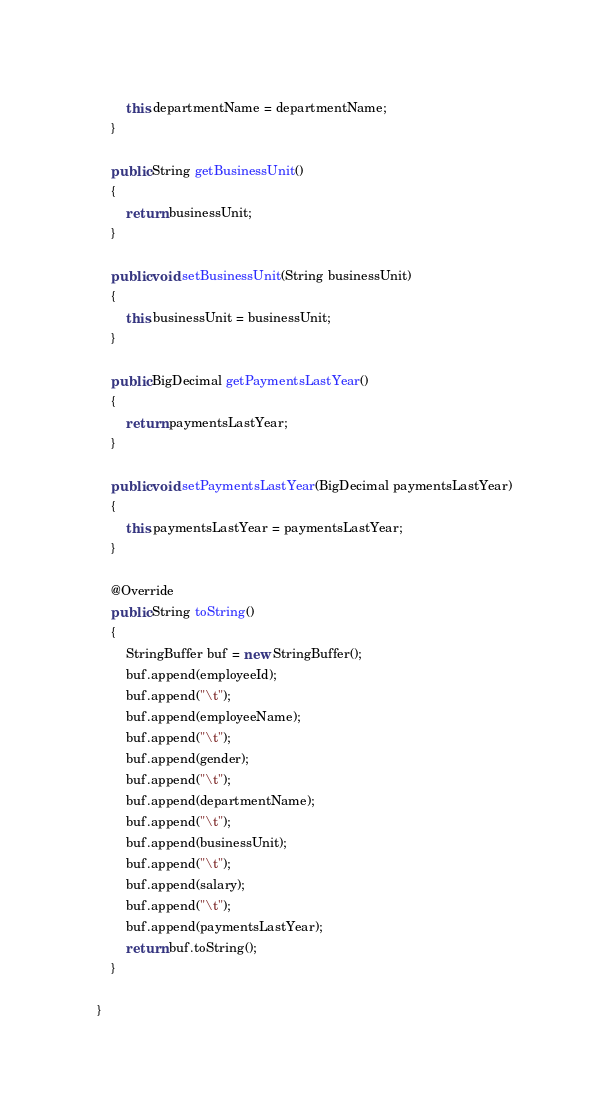Convert code to text. <code><loc_0><loc_0><loc_500><loc_500><_Java_>        this.departmentName = departmentName;
    }

    public String getBusinessUnit()
    {
        return businessUnit;
    }

    public void setBusinessUnit(String businessUnit)
    {
        this.businessUnit = businessUnit;
    }

    public BigDecimal getPaymentsLastYear()
    {
        return paymentsLastYear;
    }

    public void setPaymentsLastYear(BigDecimal paymentsLastYear)
    {
        this.paymentsLastYear = paymentsLastYear;
    }

    @Override
    public String toString()
    {
        StringBuffer buf = new StringBuffer();
        buf.append(employeeId);
        buf.append("\t");
        buf.append(employeeName);
        buf.append("\t");
        buf.append(gender);
        buf.append("\t");
        buf.append(departmentName);
        buf.append("\t");
        buf.append(businessUnit);
        buf.append("\t");
        buf.append(salary);
        buf.append("\t");
        buf.append(paymentsLastYear);
        return buf.toString();
    }
    
}
</code> 